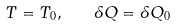<formula> <loc_0><loc_0><loc_500><loc_500>T = T _ { 0 } , \quad \delta Q = \delta Q _ { 0 }</formula> 